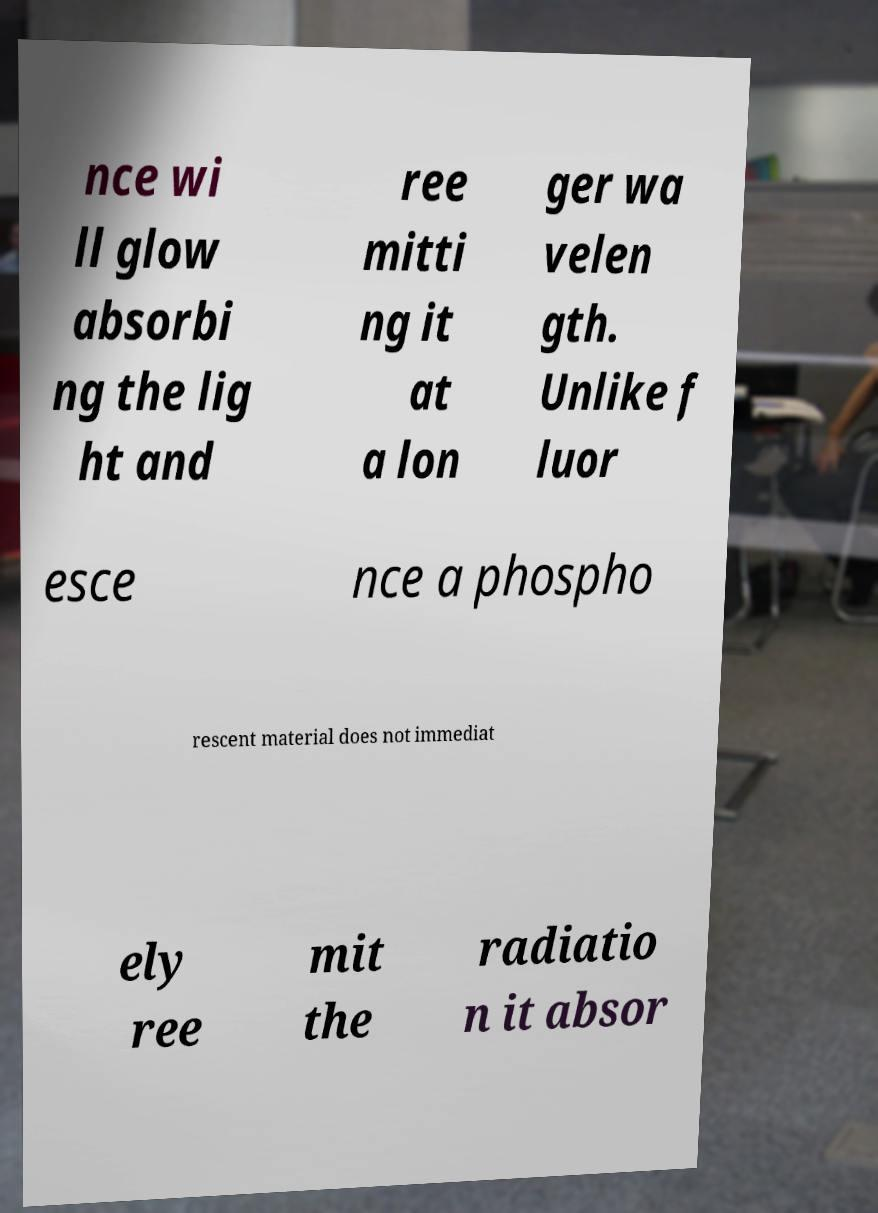There's text embedded in this image that I need extracted. Can you transcribe it verbatim? nce wi ll glow absorbi ng the lig ht and ree mitti ng it at a lon ger wa velen gth. Unlike f luor esce nce a phospho rescent material does not immediat ely ree mit the radiatio n it absor 